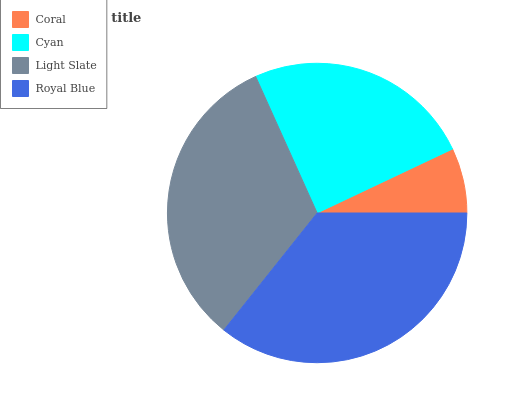Is Coral the minimum?
Answer yes or no. Yes. Is Royal Blue the maximum?
Answer yes or no. Yes. Is Cyan the minimum?
Answer yes or no. No. Is Cyan the maximum?
Answer yes or no. No. Is Cyan greater than Coral?
Answer yes or no. Yes. Is Coral less than Cyan?
Answer yes or no. Yes. Is Coral greater than Cyan?
Answer yes or no. No. Is Cyan less than Coral?
Answer yes or no. No. Is Light Slate the high median?
Answer yes or no. Yes. Is Cyan the low median?
Answer yes or no. Yes. Is Coral the high median?
Answer yes or no. No. Is Light Slate the low median?
Answer yes or no. No. 